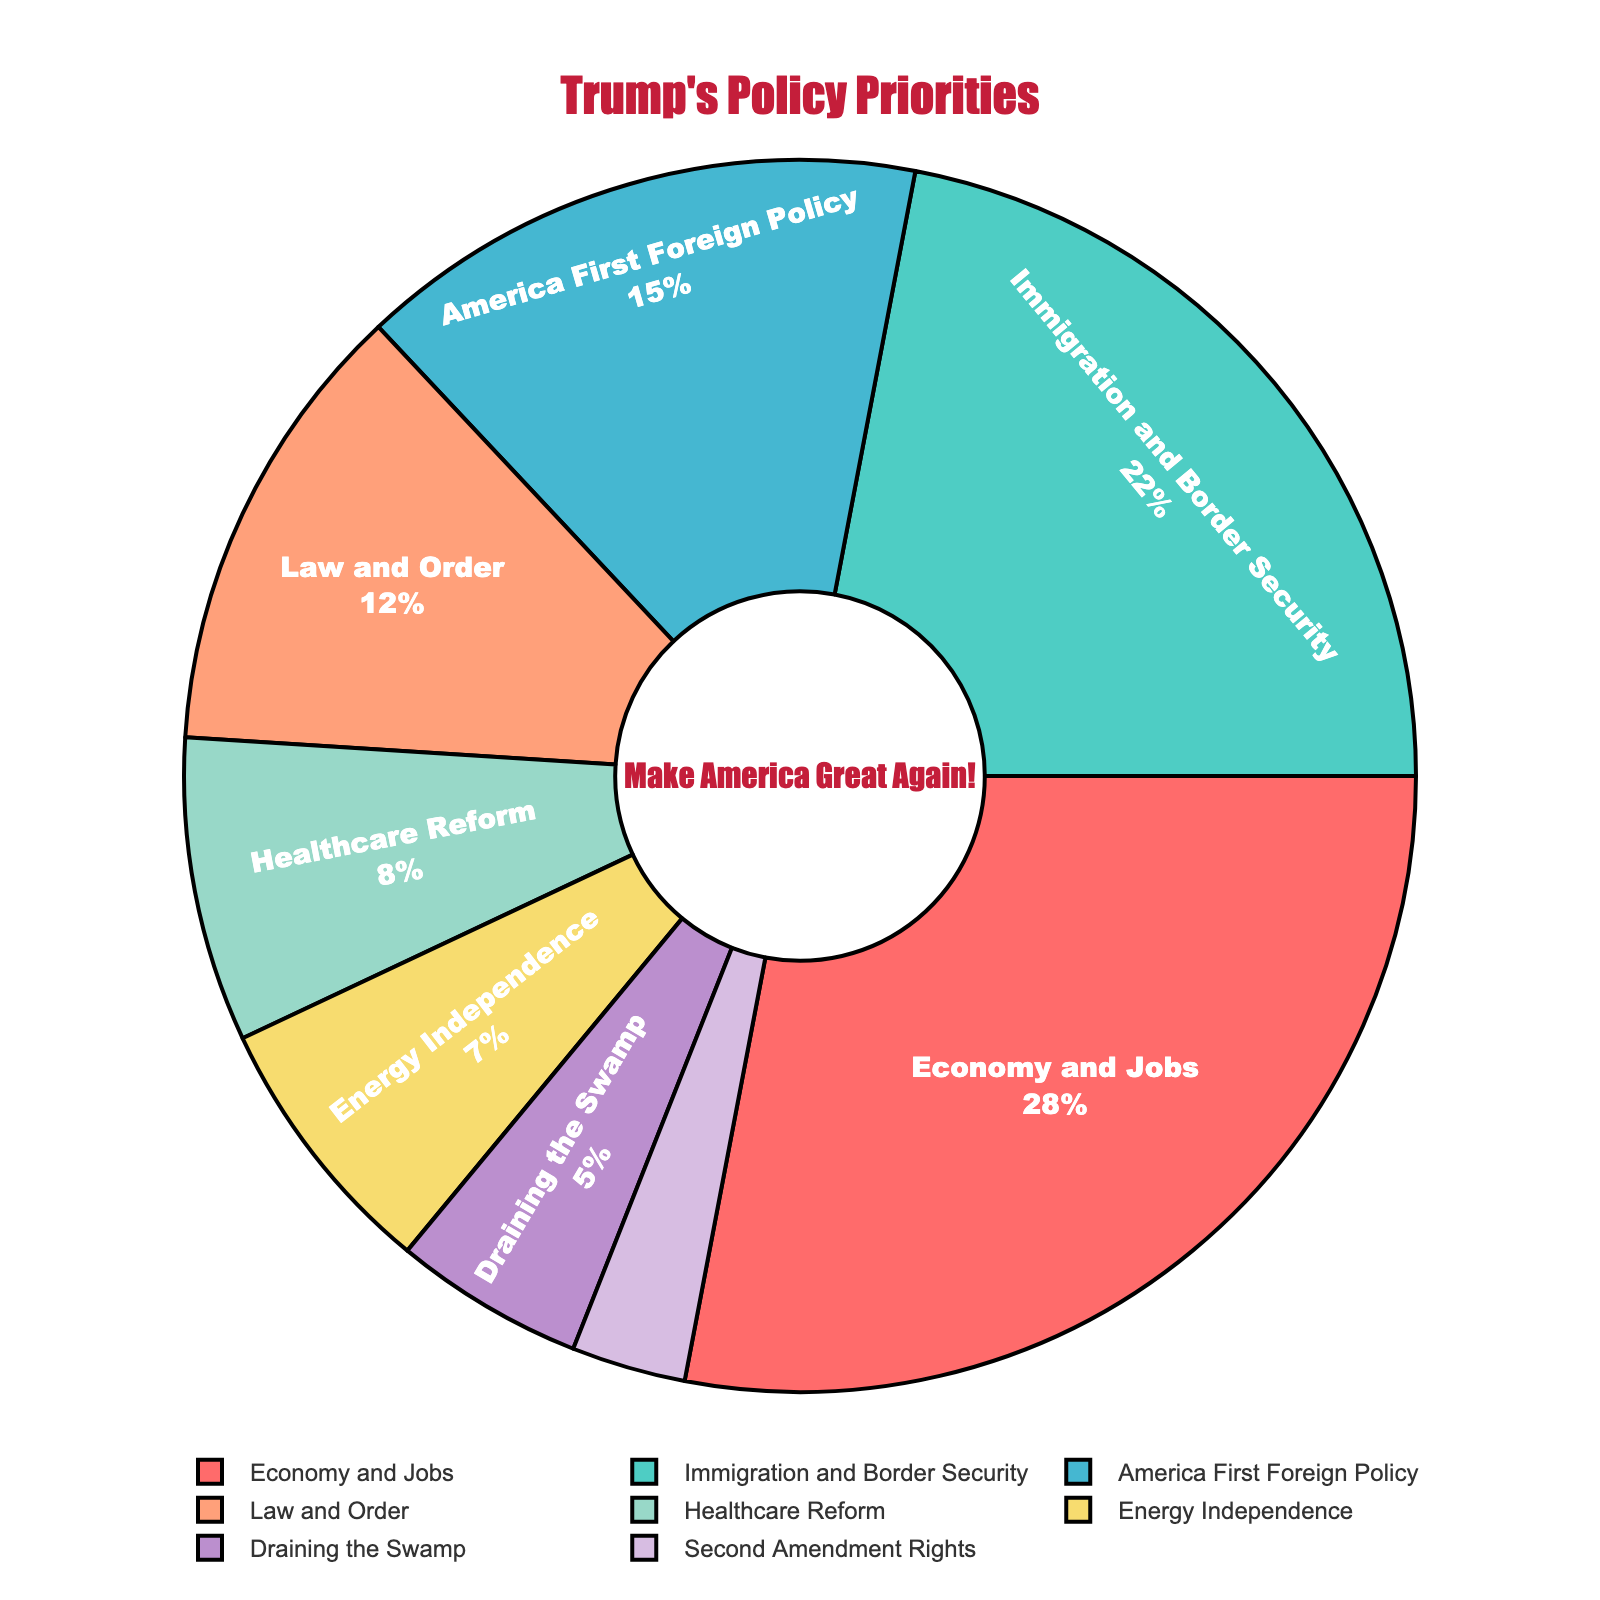What percentage of Trump's policy priorities is dedicated to Immigration and Border Security and Law and Order combined? First, find the percentage of Immigration and Border Security (22%) and Law and Order (12%). Next, add these two percentages together: 22% + 12% = 34%
Answer: 34% Which policy topic has the highest percentage in Trump's policy priorities? Look for the segment of the pie chart with the largest area, which is labeled "Economy and Jobs" with 28%
Answer: Economy and Jobs How much more focus does Trump place on Economy and Jobs compared to Second Amendment Rights? Subtract the percentage of Second Amendment Rights (3%) from the percentage of Economy and Jobs (28%): 28% - 3% = 25%
Answer: 25% What is the average percentage of Trump's policy priorities across all mentioned topics? Add all the percentages: 28% + 22% + 15% + 12% + 8% + 7% + 5% + 3% = 100%. Then divide by the number of topics: 100% ÷ 8 = 12.5%
Answer: 12.5% Which policy priority receives the least focus and what is its percentage? Identify the smallest segment in the pie chart, which is labeled "Second Amendment Rights" with 3%
Answer: Second Amendment Rights, 3% How many policy topics allocate more than 10% of the total priorities? Identify and count the segments with percentages higher than 10%: Economy and Jobs (28%), Immigration and Border Security (22%), America First Foreign Policy (15%), and Law and Order (12%). There are 4 segments
Answer: 4 Is the percentage focus on Healthcare Reform higher or lower than Energy Independence, and by how much? Compare the percentages: Healthcare Reform (8%) and Energy Independence (7%). Calculate the difference: 8% - 7% = 1%
Answer: Higher by 1% Among the priorities listed, how much combined focus is given to Energy Independence, Draining the Swamp, and the Second Amendment Rights? Add the percentages of these topics: Energy Independence (7%), Draining the Swamp (5%), Second Amendment Rights (3%): 7% + 5% + 3% = 15%
Answer: 15% What percentage difference exists between the highest (Economy and Jobs) and the lowest (Second Amendment Rights) policy priorities? Subtract the lowest percentage (3%) from the highest percentage (28%): 28% - 3% = 25%
Answer: 25% Which color is used to represent America First Foreign Policy in the pie chart? Locate the segment labeled "America First Foreign Policy" and note its color, which is blue
Answer: Blue 